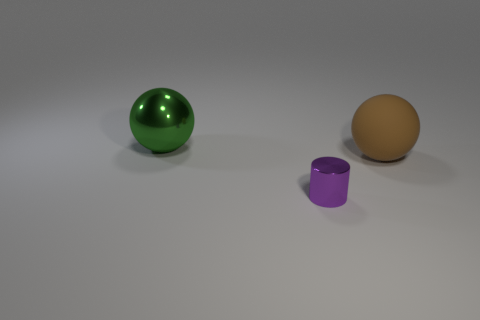Add 1 big green matte cylinders. How many big green matte cylinders exist? 1 Add 2 big yellow shiny things. How many objects exist? 5 Subtract 0 cyan cylinders. How many objects are left? 3 Subtract all cylinders. How many objects are left? 2 Subtract 1 cylinders. How many cylinders are left? 0 Subtract all purple balls. Subtract all green cylinders. How many balls are left? 2 Subtract all green balls. How many brown cylinders are left? 0 Subtract all large matte things. Subtract all large brown rubber things. How many objects are left? 1 Add 2 big shiny things. How many big shiny things are left? 3 